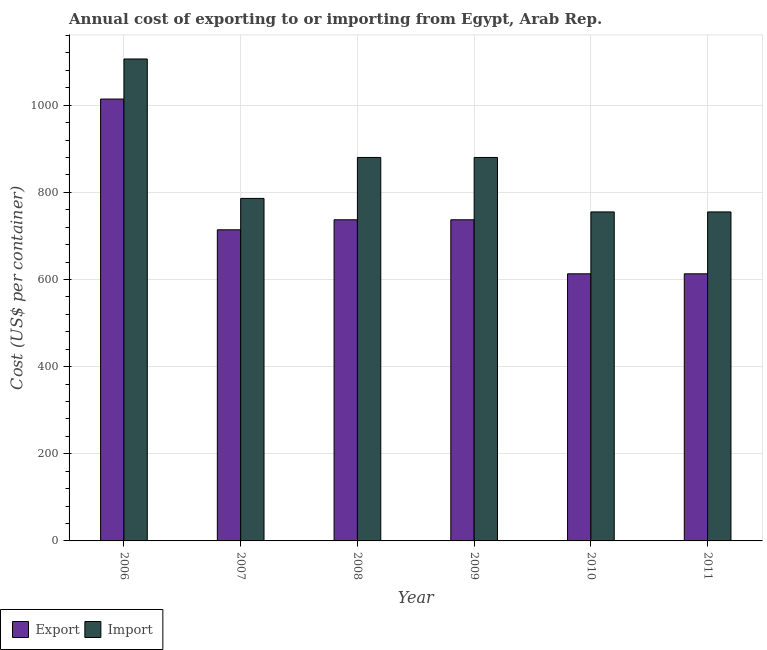How many groups of bars are there?
Give a very brief answer. 6. How many bars are there on the 6th tick from the left?
Keep it short and to the point. 2. What is the import cost in 2009?
Provide a succinct answer. 880. Across all years, what is the maximum import cost?
Keep it short and to the point. 1106. Across all years, what is the minimum export cost?
Keep it short and to the point. 613. In which year was the import cost maximum?
Your answer should be very brief. 2006. In which year was the import cost minimum?
Make the answer very short. 2010. What is the total import cost in the graph?
Provide a succinct answer. 5162. What is the difference between the import cost in 2007 and that in 2011?
Ensure brevity in your answer.  31. What is the difference between the export cost in 2011 and the import cost in 2006?
Make the answer very short. -401. What is the average import cost per year?
Provide a succinct answer. 860.33. What is the ratio of the export cost in 2008 to that in 2011?
Provide a succinct answer. 1.2. What is the difference between the highest and the second highest import cost?
Offer a very short reply. 226. What is the difference between the highest and the lowest export cost?
Your answer should be very brief. 401. In how many years, is the import cost greater than the average import cost taken over all years?
Give a very brief answer. 3. Is the sum of the import cost in 2008 and 2010 greater than the maximum export cost across all years?
Offer a terse response. Yes. What does the 1st bar from the left in 2010 represents?
Your answer should be compact. Export. What does the 1st bar from the right in 2009 represents?
Offer a terse response. Import. How many bars are there?
Your answer should be very brief. 12. Where does the legend appear in the graph?
Your response must be concise. Bottom left. What is the title of the graph?
Make the answer very short. Annual cost of exporting to or importing from Egypt, Arab Rep. Does "Primary completion rate" appear as one of the legend labels in the graph?
Provide a succinct answer. No. What is the label or title of the X-axis?
Offer a very short reply. Year. What is the label or title of the Y-axis?
Provide a succinct answer. Cost (US$ per container). What is the Cost (US$ per container) of Export in 2006?
Make the answer very short. 1014. What is the Cost (US$ per container) in Import in 2006?
Your response must be concise. 1106. What is the Cost (US$ per container) of Export in 2007?
Provide a short and direct response. 714. What is the Cost (US$ per container) in Import in 2007?
Ensure brevity in your answer.  786. What is the Cost (US$ per container) of Export in 2008?
Provide a succinct answer. 737. What is the Cost (US$ per container) of Import in 2008?
Ensure brevity in your answer.  880. What is the Cost (US$ per container) of Export in 2009?
Offer a terse response. 737. What is the Cost (US$ per container) of Import in 2009?
Provide a succinct answer. 880. What is the Cost (US$ per container) of Export in 2010?
Make the answer very short. 613. What is the Cost (US$ per container) in Import in 2010?
Keep it short and to the point. 755. What is the Cost (US$ per container) of Export in 2011?
Your response must be concise. 613. What is the Cost (US$ per container) of Import in 2011?
Make the answer very short. 755. Across all years, what is the maximum Cost (US$ per container) in Export?
Keep it short and to the point. 1014. Across all years, what is the maximum Cost (US$ per container) in Import?
Keep it short and to the point. 1106. Across all years, what is the minimum Cost (US$ per container) in Export?
Keep it short and to the point. 613. Across all years, what is the minimum Cost (US$ per container) of Import?
Your answer should be compact. 755. What is the total Cost (US$ per container) in Export in the graph?
Offer a terse response. 4428. What is the total Cost (US$ per container) of Import in the graph?
Make the answer very short. 5162. What is the difference between the Cost (US$ per container) of Export in 2006 and that in 2007?
Keep it short and to the point. 300. What is the difference between the Cost (US$ per container) in Import in 2006 and that in 2007?
Provide a succinct answer. 320. What is the difference between the Cost (US$ per container) in Export in 2006 and that in 2008?
Give a very brief answer. 277. What is the difference between the Cost (US$ per container) in Import in 2006 and that in 2008?
Ensure brevity in your answer.  226. What is the difference between the Cost (US$ per container) of Export in 2006 and that in 2009?
Offer a terse response. 277. What is the difference between the Cost (US$ per container) in Import in 2006 and that in 2009?
Your answer should be very brief. 226. What is the difference between the Cost (US$ per container) of Export in 2006 and that in 2010?
Your response must be concise. 401. What is the difference between the Cost (US$ per container) in Import in 2006 and that in 2010?
Keep it short and to the point. 351. What is the difference between the Cost (US$ per container) of Export in 2006 and that in 2011?
Offer a very short reply. 401. What is the difference between the Cost (US$ per container) in Import in 2006 and that in 2011?
Provide a short and direct response. 351. What is the difference between the Cost (US$ per container) of Export in 2007 and that in 2008?
Your answer should be compact. -23. What is the difference between the Cost (US$ per container) in Import in 2007 and that in 2008?
Ensure brevity in your answer.  -94. What is the difference between the Cost (US$ per container) of Import in 2007 and that in 2009?
Provide a short and direct response. -94. What is the difference between the Cost (US$ per container) in Export in 2007 and that in 2010?
Your response must be concise. 101. What is the difference between the Cost (US$ per container) in Import in 2007 and that in 2010?
Provide a succinct answer. 31. What is the difference between the Cost (US$ per container) in Export in 2007 and that in 2011?
Offer a terse response. 101. What is the difference between the Cost (US$ per container) of Export in 2008 and that in 2010?
Provide a short and direct response. 124. What is the difference between the Cost (US$ per container) in Import in 2008 and that in 2010?
Offer a terse response. 125. What is the difference between the Cost (US$ per container) of Export in 2008 and that in 2011?
Your answer should be compact. 124. What is the difference between the Cost (US$ per container) of Import in 2008 and that in 2011?
Offer a terse response. 125. What is the difference between the Cost (US$ per container) in Export in 2009 and that in 2010?
Offer a terse response. 124. What is the difference between the Cost (US$ per container) of Import in 2009 and that in 2010?
Make the answer very short. 125. What is the difference between the Cost (US$ per container) of Export in 2009 and that in 2011?
Provide a succinct answer. 124. What is the difference between the Cost (US$ per container) of Import in 2009 and that in 2011?
Make the answer very short. 125. What is the difference between the Cost (US$ per container) of Import in 2010 and that in 2011?
Provide a short and direct response. 0. What is the difference between the Cost (US$ per container) of Export in 2006 and the Cost (US$ per container) of Import in 2007?
Ensure brevity in your answer.  228. What is the difference between the Cost (US$ per container) in Export in 2006 and the Cost (US$ per container) in Import in 2008?
Offer a terse response. 134. What is the difference between the Cost (US$ per container) in Export in 2006 and the Cost (US$ per container) in Import in 2009?
Offer a terse response. 134. What is the difference between the Cost (US$ per container) of Export in 2006 and the Cost (US$ per container) of Import in 2010?
Offer a terse response. 259. What is the difference between the Cost (US$ per container) in Export in 2006 and the Cost (US$ per container) in Import in 2011?
Keep it short and to the point. 259. What is the difference between the Cost (US$ per container) of Export in 2007 and the Cost (US$ per container) of Import in 2008?
Offer a terse response. -166. What is the difference between the Cost (US$ per container) in Export in 2007 and the Cost (US$ per container) in Import in 2009?
Give a very brief answer. -166. What is the difference between the Cost (US$ per container) in Export in 2007 and the Cost (US$ per container) in Import in 2010?
Provide a short and direct response. -41. What is the difference between the Cost (US$ per container) of Export in 2007 and the Cost (US$ per container) of Import in 2011?
Keep it short and to the point. -41. What is the difference between the Cost (US$ per container) in Export in 2008 and the Cost (US$ per container) in Import in 2009?
Your response must be concise. -143. What is the difference between the Cost (US$ per container) of Export in 2008 and the Cost (US$ per container) of Import in 2011?
Offer a terse response. -18. What is the difference between the Cost (US$ per container) in Export in 2009 and the Cost (US$ per container) in Import in 2010?
Your response must be concise. -18. What is the difference between the Cost (US$ per container) of Export in 2009 and the Cost (US$ per container) of Import in 2011?
Your answer should be compact. -18. What is the difference between the Cost (US$ per container) in Export in 2010 and the Cost (US$ per container) in Import in 2011?
Offer a very short reply. -142. What is the average Cost (US$ per container) in Export per year?
Provide a succinct answer. 738. What is the average Cost (US$ per container) in Import per year?
Make the answer very short. 860.33. In the year 2006, what is the difference between the Cost (US$ per container) of Export and Cost (US$ per container) of Import?
Provide a short and direct response. -92. In the year 2007, what is the difference between the Cost (US$ per container) in Export and Cost (US$ per container) in Import?
Provide a short and direct response. -72. In the year 2008, what is the difference between the Cost (US$ per container) in Export and Cost (US$ per container) in Import?
Offer a very short reply. -143. In the year 2009, what is the difference between the Cost (US$ per container) of Export and Cost (US$ per container) of Import?
Your answer should be compact. -143. In the year 2010, what is the difference between the Cost (US$ per container) of Export and Cost (US$ per container) of Import?
Your answer should be compact. -142. In the year 2011, what is the difference between the Cost (US$ per container) of Export and Cost (US$ per container) of Import?
Your answer should be compact. -142. What is the ratio of the Cost (US$ per container) of Export in 2006 to that in 2007?
Provide a short and direct response. 1.42. What is the ratio of the Cost (US$ per container) of Import in 2006 to that in 2007?
Your answer should be very brief. 1.41. What is the ratio of the Cost (US$ per container) in Export in 2006 to that in 2008?
Provide a succinct answer. 1.38. What is the ratio of the Cost (US$ per container) of Import in 2006 to that in 2008?
Offer a very short reply. 1.26. What is the ratio of the Cost (US$ per container) of Export in 2006 to that in 2009?
Provide a succinct answer. 1.38. What is the ratio of the Cost (US$ per container) in Import in 2006 to that in 2009?
Offer a terse response. 1.26. What is the ratio of the Cost (US$ per container) in Export in 2006 to that in 2010?
Ensure brevity in your answer.  1.65. What is the ratio of the Cost (US$ per container) in Import in 2006 to that in 2010?
Offer a very short reply. 1.46. What is the ratio of the Cost (US$ per container) in Export in 2006 to that in 2011?
Make the answer very short. 1.65. What is the ratio of the Cost (US$ per container) in Import in 2006 to that in 2011?
Ensure brevity in your answer.  1.46. What is the ratio of the Cost (US$ per container) of Export in 2007 to that in 2008?
Offer a very short reply. 0.97. What is the ratio of the Cost (US$ per container) in Import in 2007 to that in 2008?
Ensure brevity in your answer.  0.89. What is the ratio of the Cost (US$ per container) of Export in 2007 to that in 2009?
Provide a short and direct response. 0.97. What is the ratio of the Cost (US$ per container) in Import in 2007 to that in 2009?
Keep it short and to the point. 0.89. What is the ratio of the Cost (US$ per container) of Export in 2007 to that in 2010?
Offer a very short reply. 1.16. What is the ratio of the Cost (US$ per container) of Import in 2007 to that in 2010?
Offer a very short reply. 1.04. What is the ratio of the Cost (US$ per container) in Export in 2007 to that in 2011?
Your answer should be very brief. 1.16. What is the ratio of the Cost (US$ per container) of Import in 2007 to that in 2011?
Give a very brief answer. 1.04. What is the ratio of the Cost (US$ per container) in Export in 2008 to that in 2009?
Your answer should be very brief. 1. What is the ratio of the Cost (US$ per container) in Export in 2008 to that in 2010?
Your response must be concise. 1.2. What is the ratio of the Cost (US$ per container) of Import in 2008 to that in 2010?
Offer a terse response. 1.17. What is the ratio of the Cost (US$ per container) in Export in 2008 to that in 2011?
Your response must be concise. 1.2. What is the ratio of the Cost (US$ per container) of Import in 2008 to that in 2011?
Keep it short and to the point. 1.17. What is the ratio of the Cost (US$ per container) in Export in 2009 to that in 2010?
Keep it short and to the point. 1.2. What is the ratio of the Cost (US$ per container) in Import in 2009 to that in 2010?
Provide a short and direct response. 1.17. What is the ratio of the Cost (US$ per container) of Export in 2009 to that in 2011?
Provide a succinct answer. 1.2. What is the ratio of the Cost (US$ per container) of Import in 2009 to that in 2011?
Give a very brief answer. 1.17. What is the ratio of the Cost (US$ per container) of Export in 2010 to that in 2011?
Make the answer very short. 1. What is the ratio of the Cost (US$ per container) of Import in 2010 to that in 2011?
Offer a terse response. 1. What is the difference between the highest and the second highest Cost (US$ per container) of Export?
Your answer should be compact. 277. What is the difference between the highest and the second highest Cost (US$ per container) in Import?
Offer a terse response. 226. What is the difference between the highest and the lowest Cost (US$ per container) of Export?
Your answer should be compact. 401. What is the difference between the highest and the lowest Cost (US$ per container) in Import?
Your answer should be compact. 351. 